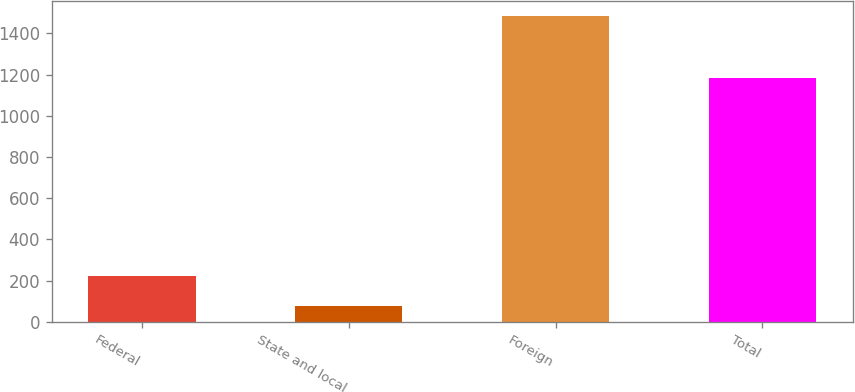<chart> <loc_0><loc_0><loc_500><loc_500><bar_chart><fcel>Federal<fcel>State and local<fcel>Foreign<fcel>Total<nl><fcel>224<fcel>75<fcel>1484<fcel>1185<nl></chart> 